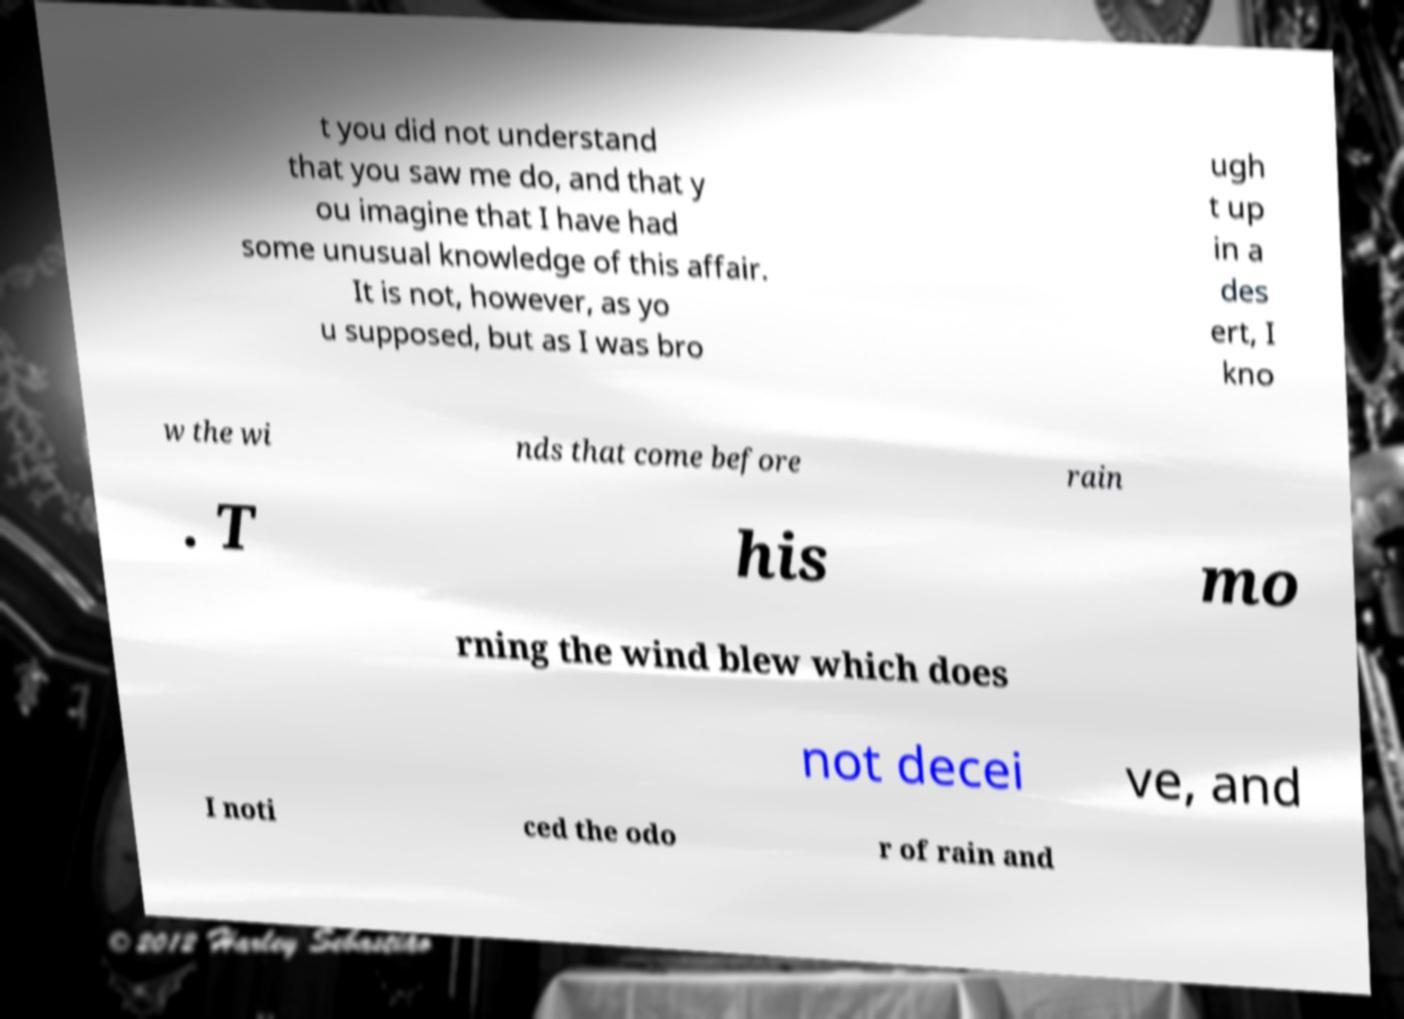Can you read and provide the text displayed in the image?This photo seems to have some interesting text. Can you extract and type it out for me? t you did not understand that you saw me do, and that y ou imagine that I have had some unusual knowledge of this affair. It is not, however, as yo u supposed, but as I was bro ugh t up in a des ert, I kno w the wi nds that come before rain . T his mo rning the wind blew which does not decei ve, and I noti ced the odo r of rain and 